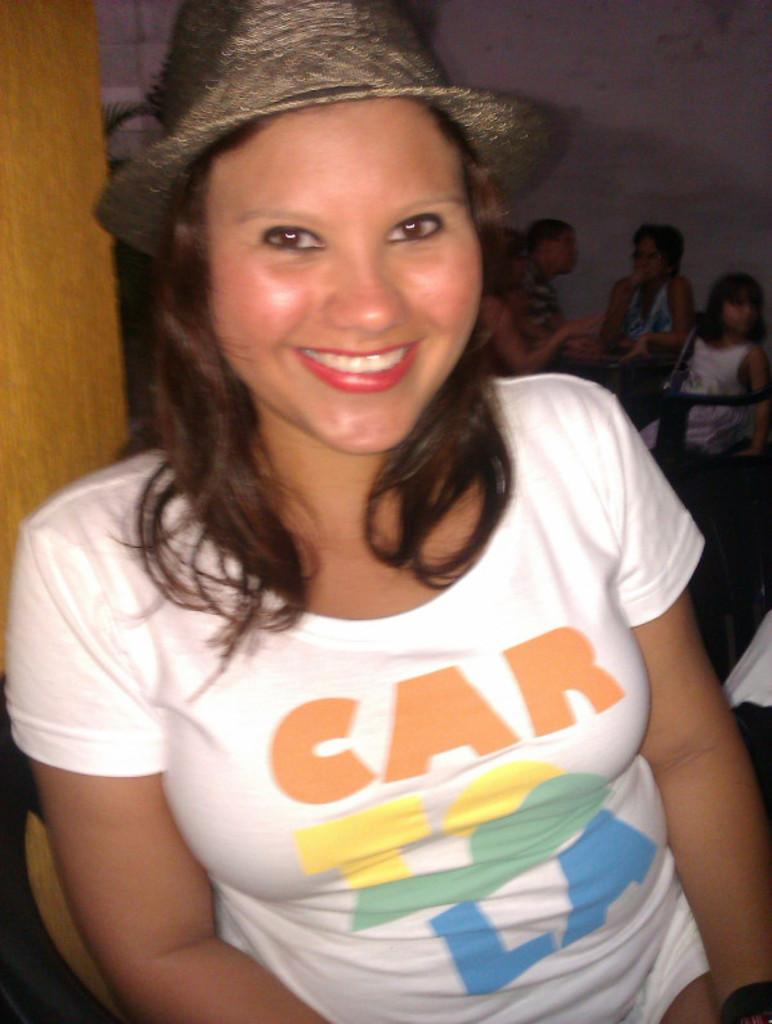What is the main setting of the image? The image is of a room. Who is the main subject in the foreground? There is a woman sitting on a chair in the foreground. What is the woman's expression in the image? The woman is smiling. Can you describe the people in the background? There is a group of people sitting on chairs in the background. What is visible on the walls in the image? There is a wall visible in the image. What type of cushion is being used for the meal in the image? There is no meal or cushion present in the image; it features a woman and a group of people sitting on chairs in a room. 